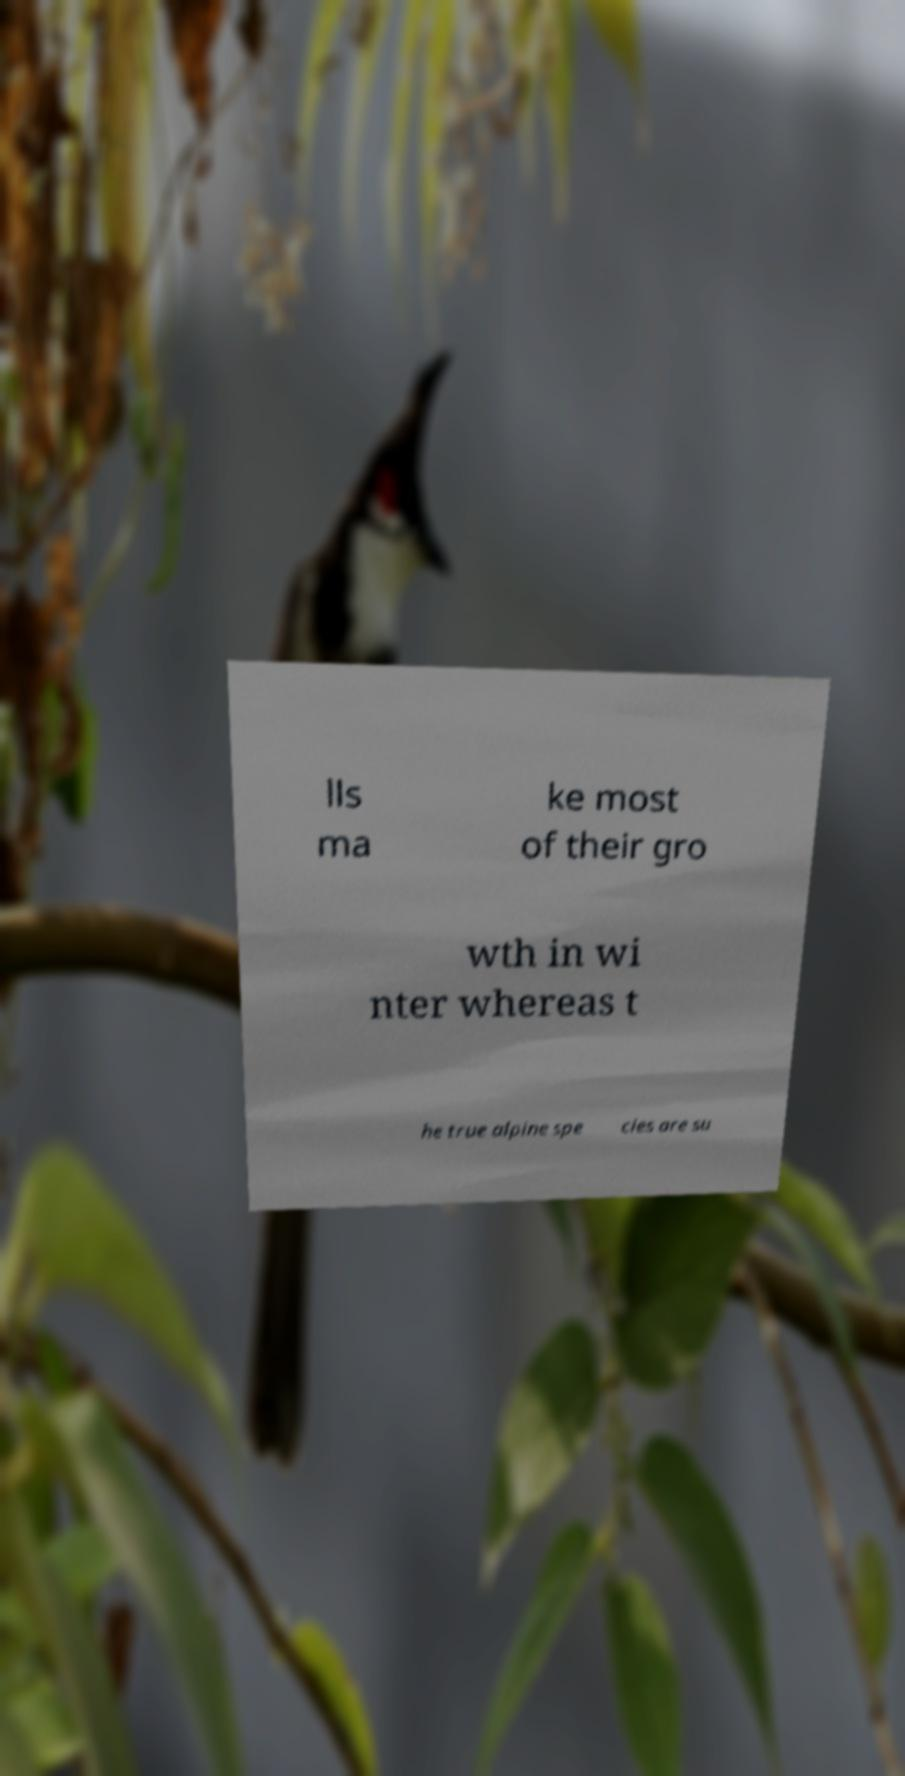Can you read and provide the text displayed in the image?This photo seems to have some interesting text. Can you extract and type it out for me? lls ma ke most of their gro wth in wi nter whereas t he true alpine spe cies are su 